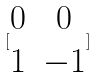<formula> <loc_0><loc_0><loc_500><loc_500>[ \begin{matrix} 0 & 0 \\ 1 & - 1 \end{matrix} ]</formula> 